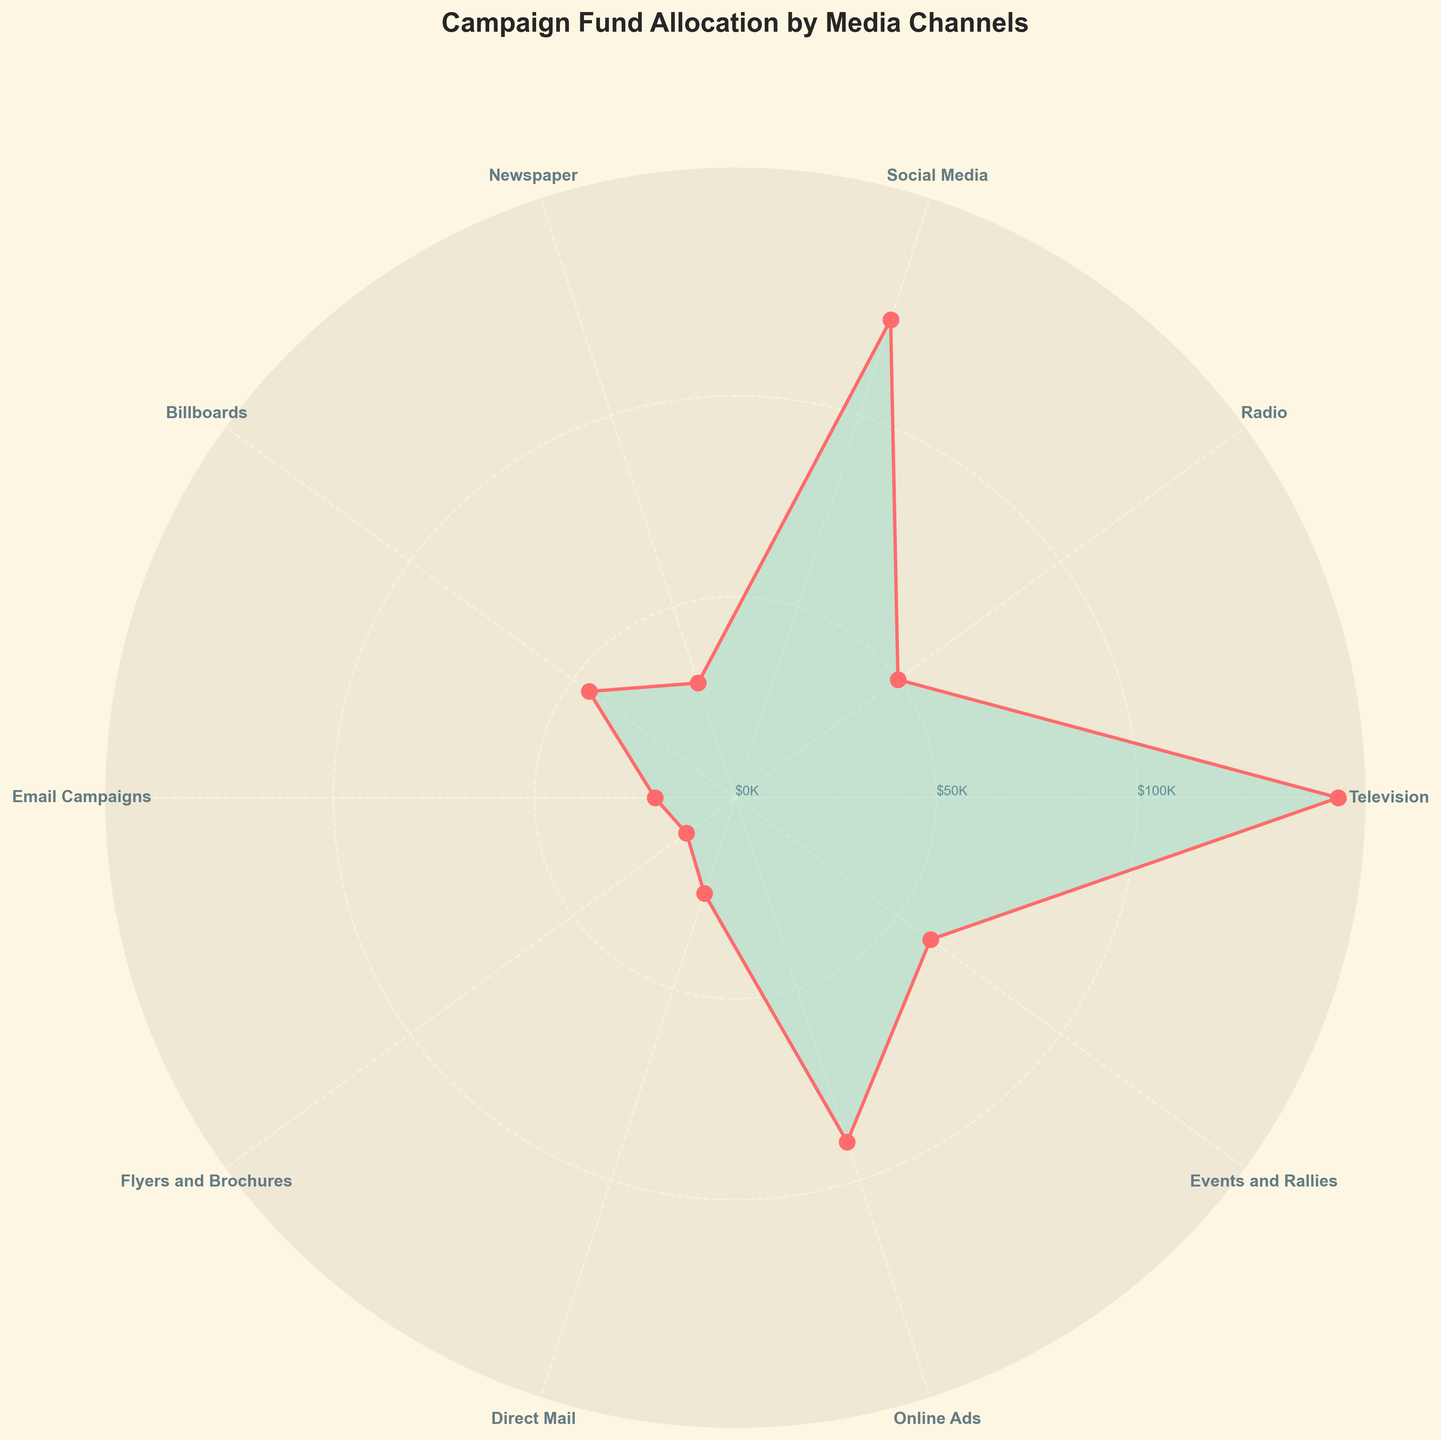Which media channel has the highest fund allocation? By looking at the plot, the highest point in the radial axis shows the maximum value. Match the highest plot point with the corresponding media channel on the angular axis.
Answer: Television Which media channel has the lowest fund allocation? The lowest point in the radial axis will show the minimum value. Match the lowest plot point with the corresponding media channel on the angular axis.
Answer: Flyers and Brochures What is the title of the plot? The title of the plot is located on top of the figure and usually provides a summary of what the plot represents.
Answer: Campaign Fund Allocation by Media Channels How many media channels are represented in the plot? Count the number of unique media channel labels around the polar chart.
Answer: 10 Which media channels have a fund allocation greater than $100,000? Identify the channels with amounts plotted above the $100,000 mark on the radial axis and associate them with the respective angular positions.
Answer: Television, Social Media What is the total fund allocation for Radio and Newspaper combined? Find the allocation amounts for Radio ($50,000) and Newspaper ($30,000), then sum them together: $50,000 + $30,000.
Answer: $80,000 Which media channel has a fund allocation closest to $70,000? Find the radial distance closest to $70,000 by looking at the plot points and matching it with the corresponding media channel.
Answer: Events and Rallies Compare the fund allocation between Online Ads and Billboards. Which one is greater? Compare the radial distances of Online Ads and Billboards. The channel with the longer radial distance has the greater fund allocation.
Answer: Online Ads What is the difference in fund allocation between Social Media and Radio? Subtract the amount for Radio ($50,000) from the amount for Social Media ($125,000): $125,000 - $50,000.
Answer: $75,000 What percentage of total fund allocation is spent on Email Campaigns? Calculate the total fund allocation by summing all amounts and then find the percentage allocated to Email Campaigns: ($20,000 / $605,000) * 100.
Answer: 3.31% 